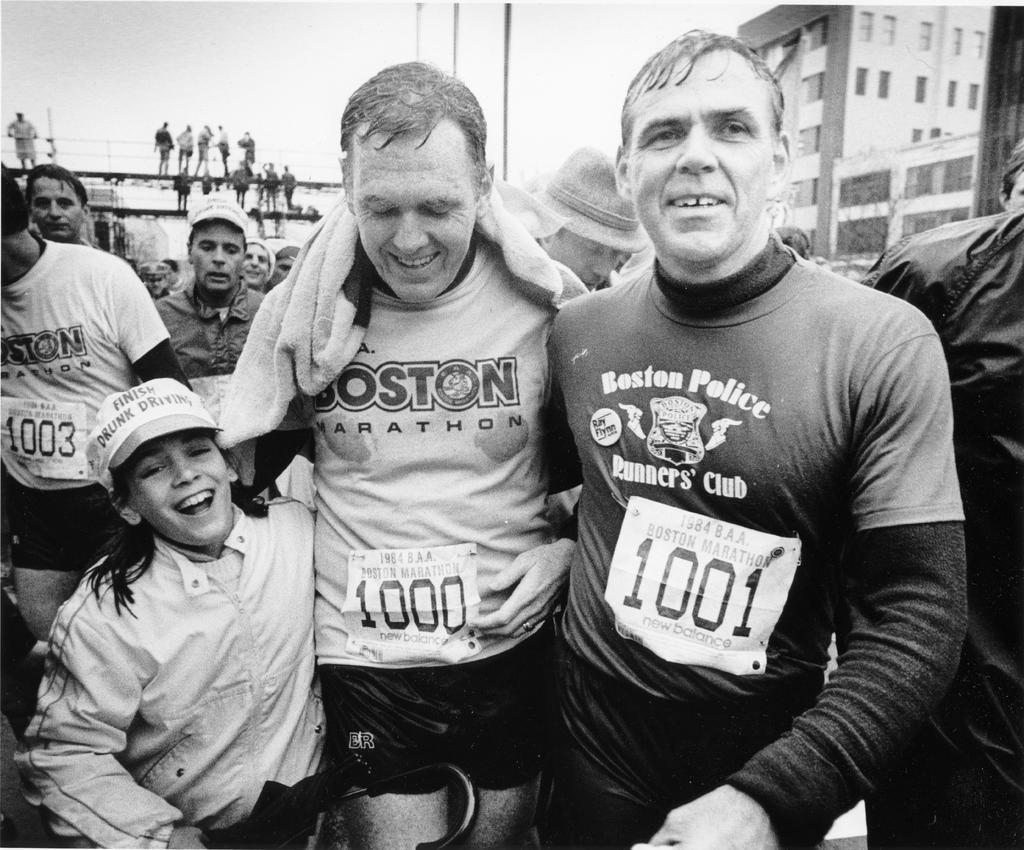Can you describe this image briefly? In this picture there are group of people standing and smiling. At the back there are group of people standing on the wall and there are buildings and poles. At the top there is sky. 